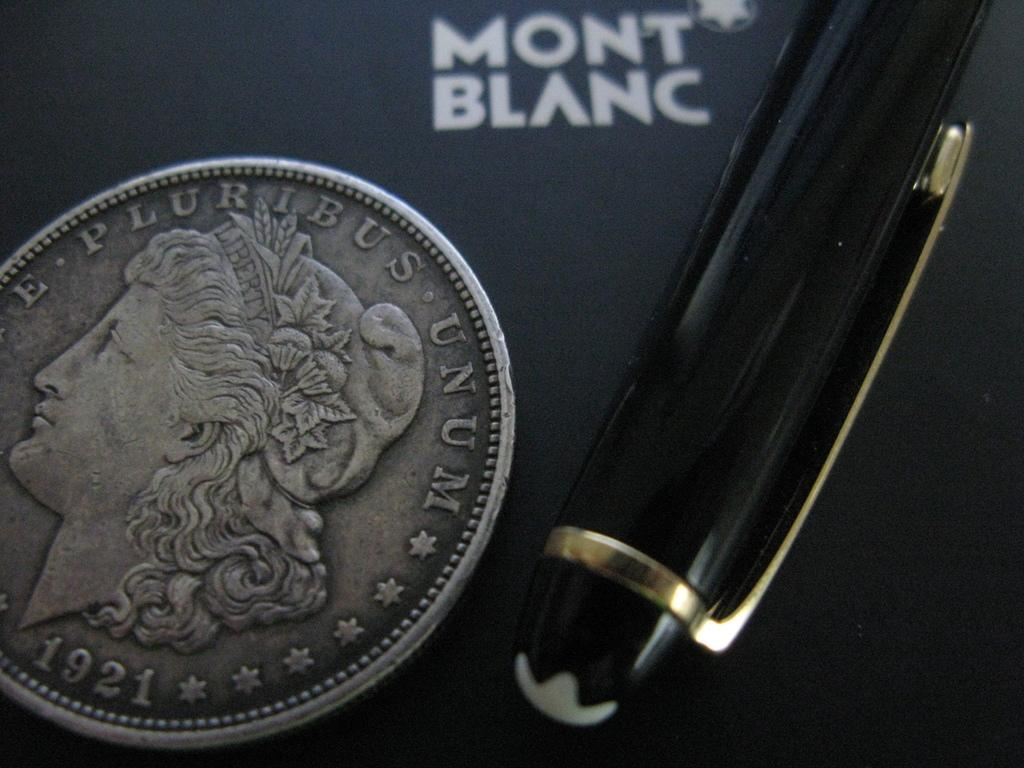<image>
Offer a succinct explanation of the picture presented. A mont blanc pen next to a 1921 quarter. 